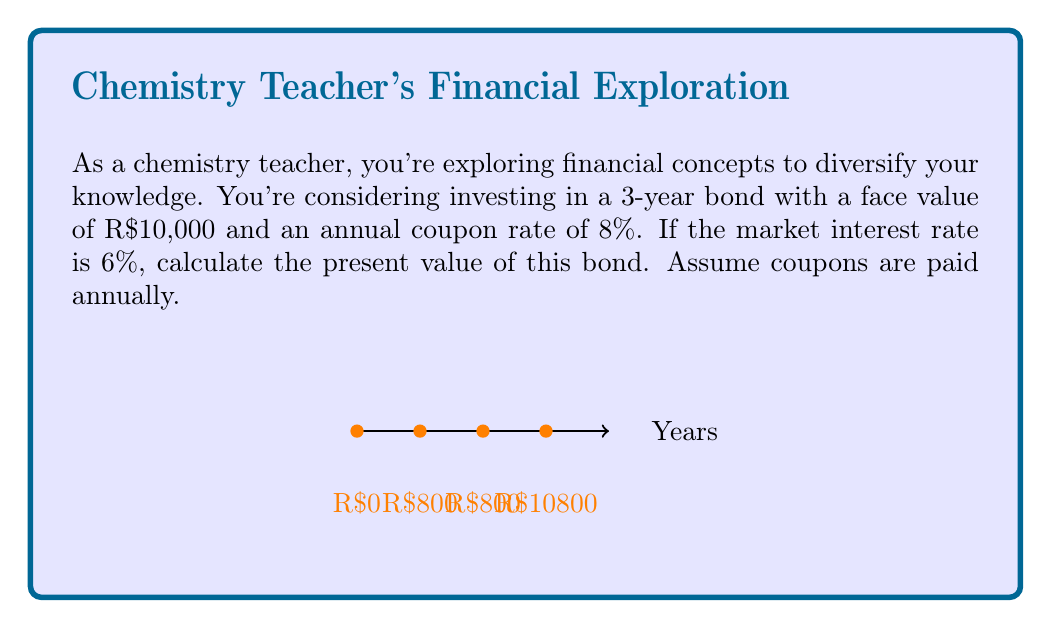What is the answer to this math problem? Let's approach this step-by-step:

1) First, identify the cash flows:
   - Annual coupons: R$10,000 * 8% = R$800 per year
   - Face value at maturity: R$10,000

2) The present value (PV) formula for a bond is:

   $$ PV = \sum_{t=1}^n \frac{C}{(1+r)^t} + \frac{F}{(1+r)^n} $$

   Where:
   $C$ = coupon payment
   $r$ = market interest rate
   $n$ = number of years
   $F$ = face value

3) Let's calculate each component:

   For coupons:
   $$ PV_{coupons} = \frac{800}{(1+0.06)^1} + \frac{800}{(1+0.06)^2} + \frac{800}{(1+0.06)^3} $$

   For face value:
   $$ PV_{face} = \frac{10,000}{(1+0.06)^3} $$

4) Calculate:
   $$ PV_{coupons} = 754.72 + 711.99 + 671.69 = 2,138.40 $$
   $$ PV_{face} = 8,396.18 $$

5) Sum up:
   $$ PV_{total} = 2,138.40 + 8,396.18 = 10,534.58 $$
Answer: R$10,534.58 